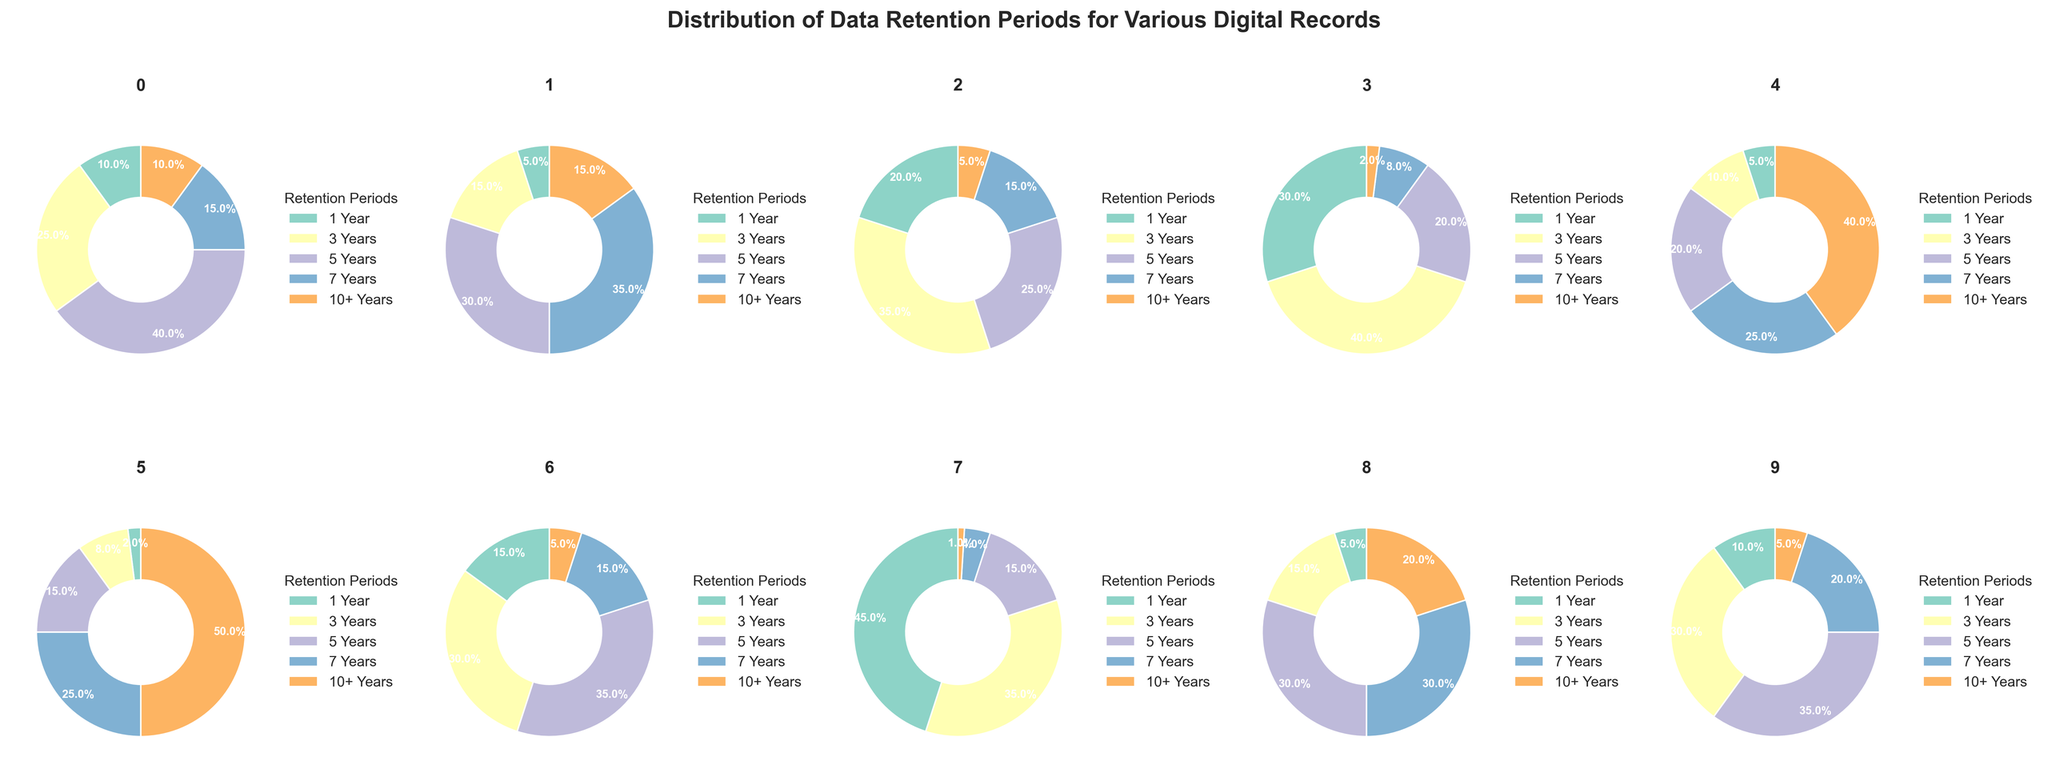Which type of digital record has the highest percentage of data retention for 1 Year? Examine the pie charts in the figure. The highest percentage for 1 Year retention is in the chart for Security Logs, which is 45%.
Answer: Security Logs What is the combined percentage of data retained for 10+ Years in Financial Records and Legal Documents? Add the percentages for 10+ Years retention in Financial Records (10%) and Legal Documents (40%). The total is 10% + 40% = 50%.
Answer: 50% Which type of digital record has the lowest percentage of data retention for 5 Years compared to all other types? Compare the 5 Years retention percentages across all pie charts. Medical Records have the lowest percentage for 5 Years retention at 15%.
Answer: Medical Records Is the percentage of data retention for 3 Years higher in Project Documentation or Employee Records? Compare the 3 Years retention percentages in the pie charts for Project Documentation (30%) and Employee Records (15%). Project Documentation has a higher percentage.
Answer: Project Documentation What is the average percentage of data retention for 7 Years across all types of digital records? Sum the 7 Years retention percentages for all types (15+35+15+8+25+25+15+4+30+20) = 192. Divide by 10 for the average: 192 / 10 = 19.2%.
Answer: 19.2% Which type of digital record has the highest percentage of data retention for 3 Years? Scan all pie charts and identify the one with the highest 3 Years retention percentage, which is Email Archives at 40%.
Answer: Email Archives What is the difference in the percentage of data retained for 5 Years between Customer Data and Educational Records? Subtract the percentage for 5 Years in Customer Data (25%) from that in Educational Records (35%): 35% - 25% = 10%.
Answer: 10% How many types of digital records have a higher percentage of data retention for 10+ Years than for 1 Year? Compare the 10+ Years and 1 Year percentages for each type. Legal Documents, Medical Records, Project Documentation, and Contracts have higher percentages for 10+ Years. Count these types (4).
Answer: 4 